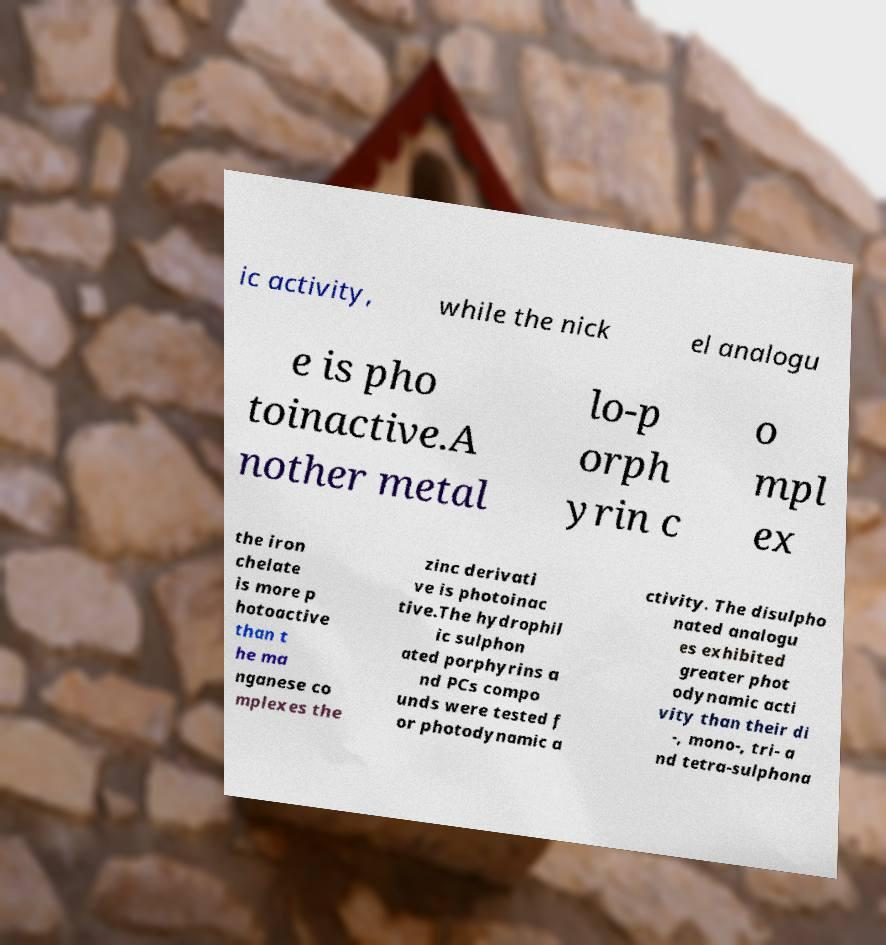Please identify and transcribe the text found in this image. ic activity, while the nick el analogu e is pho toinactive.A nother metal lo-p orph yrin c o mpl ex the iron chelate is more p hotoactive than t he ma nganese co mplexes the zinc derivati ve is photoinac tive.The hydrophil ic sulphon ated porphyrins a nd PCs compo unds were tested f or photodynamic a ctivity. The disulpho nated analogu es exhibited greater phot odynamic acti vity than their di -, mono-, tri- a nd tetra-sulphona 